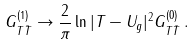Convert formula to latex. <formula><loc_0><loc_0><loc_500><loc_500>G _ { T { \bar { T } } } ^ { ( 1 ) } \rightarrow \frac { 2 } { \pi } \ln | T - U _ { g } | ^ { 2 } G _ { T { \bar { T } } } ^ { ( 0 ) } \, .</formula> 